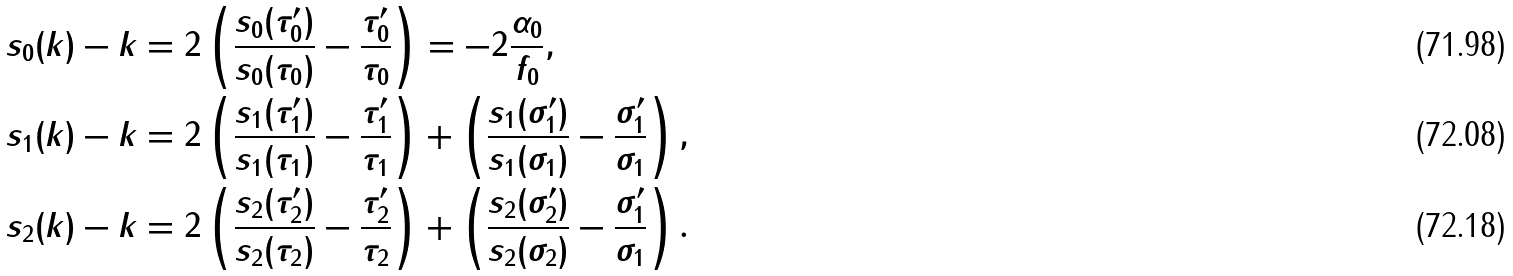Convert formula to latex. <formula><loc_0><loc_0><loc_500><loc_500>s _ { 0 } ( k ) - k & = 2 \left ( \frac { s _ { 0 } ( \tau _ { 0 } ^ { \prime } ) } { s _ { 0 } ( \tau _ { 0 } ) } - \frac { \tau _ { 0 } ^ { \prime } } { \tau _ { 0 } } \right ) = - 2 \frac { \alpha _ { 0 } } { f _ { 0 } } , \\ s _ { 1 } ( k ) - k & = 2 \left ( \frac { s _ { 1 } ( \tau _ { 1 } ^ { \prime } ) } { s _ { 1 } ( \tau _ { 1 } ) } - \frac { \tau _ { 1 } ^ { \prime } } { \tau _ { 1 } } \right ) + \left ( \frac { s _ { 1 } ( \sigma _ { 1 } ^ { \prime } ) } { s _ { 1 } ( \sigma _ { 1 } ) } - \frac { \sigma _ { 1 } ^ { \prime } } { \sigma _ { 1 } } \right ) , \\ s _ { 2 } ( k ) - k & = 2 \left ( \frac { s _ { 2 } ( \tau _ { 2 } ^ { \prime } ) } { s _ { 2 } ( \tau _ { 2 } ) } - \frac { \tau _ { 2 } ^ { \prime } } { \tau _ { 2 } } \right ) + \left ( \frac { s _ { 2 } ( \sigma _ { 2 } ^ { \prime } ) } { s _ { 2 } ( \sigma _ { 2 } ) } - \frac { \sigma _ { 1 } ^ { \prime } } { \sigma _ { 1 } } \right ) .</formula> 